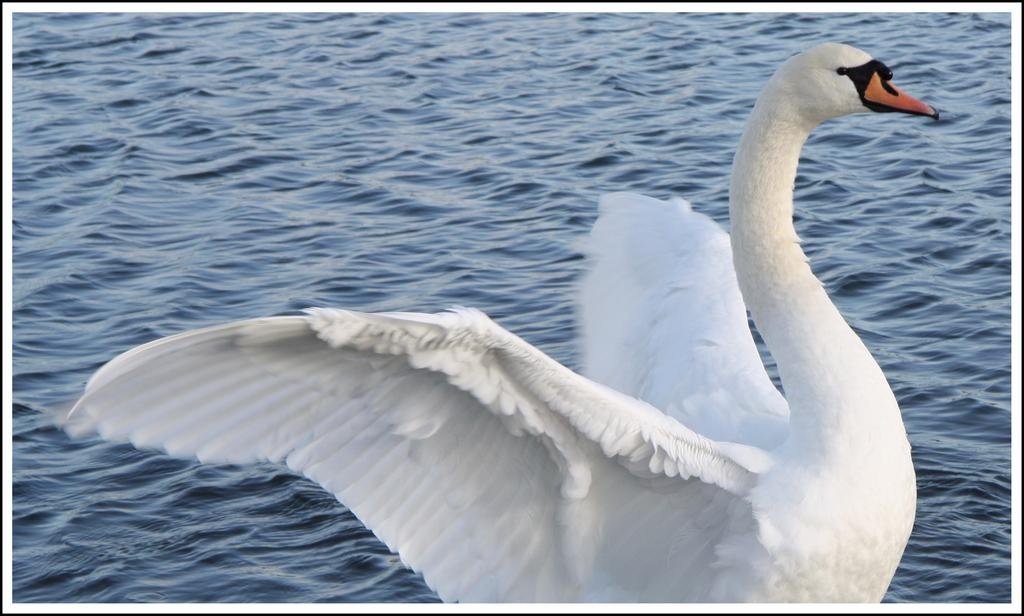What animal is present in the image? There is a swan in the image. What color is the swan? The swan is white. What is at the bottom of the image? There is water at the bottom of the image. What color is the water? The water is blue. How many apples are floating in the water in the image? There are no apples present in the image; it features a swan in water. What type of glass is being used to answer questions about the image? There is no glass being used to answer questions about the image; the questions are being answered verbally. 